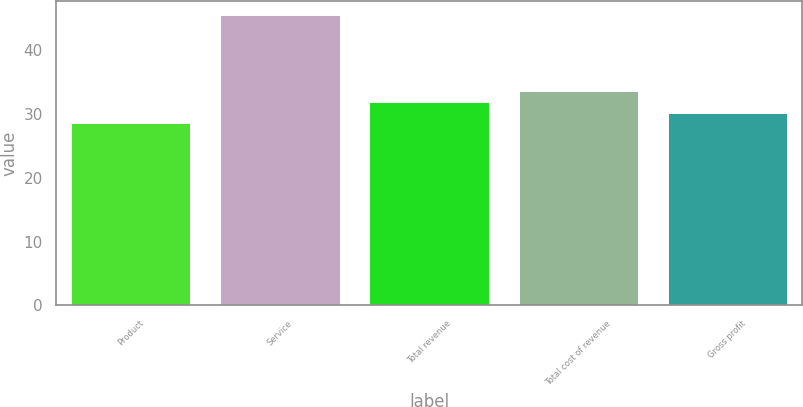Convert chart. <chart><loc_0><loc_0><loc_500><loc_500><bar_chart><fcel>Product<fcel>Service<fcel>Total revenue<fcel>Total cost of revenue<fcel>Gross profit<nl><fcel>28.5<fcel>45.4<fcel>31.88<fcel>33.57<fcel>30.19<nl></chart> 